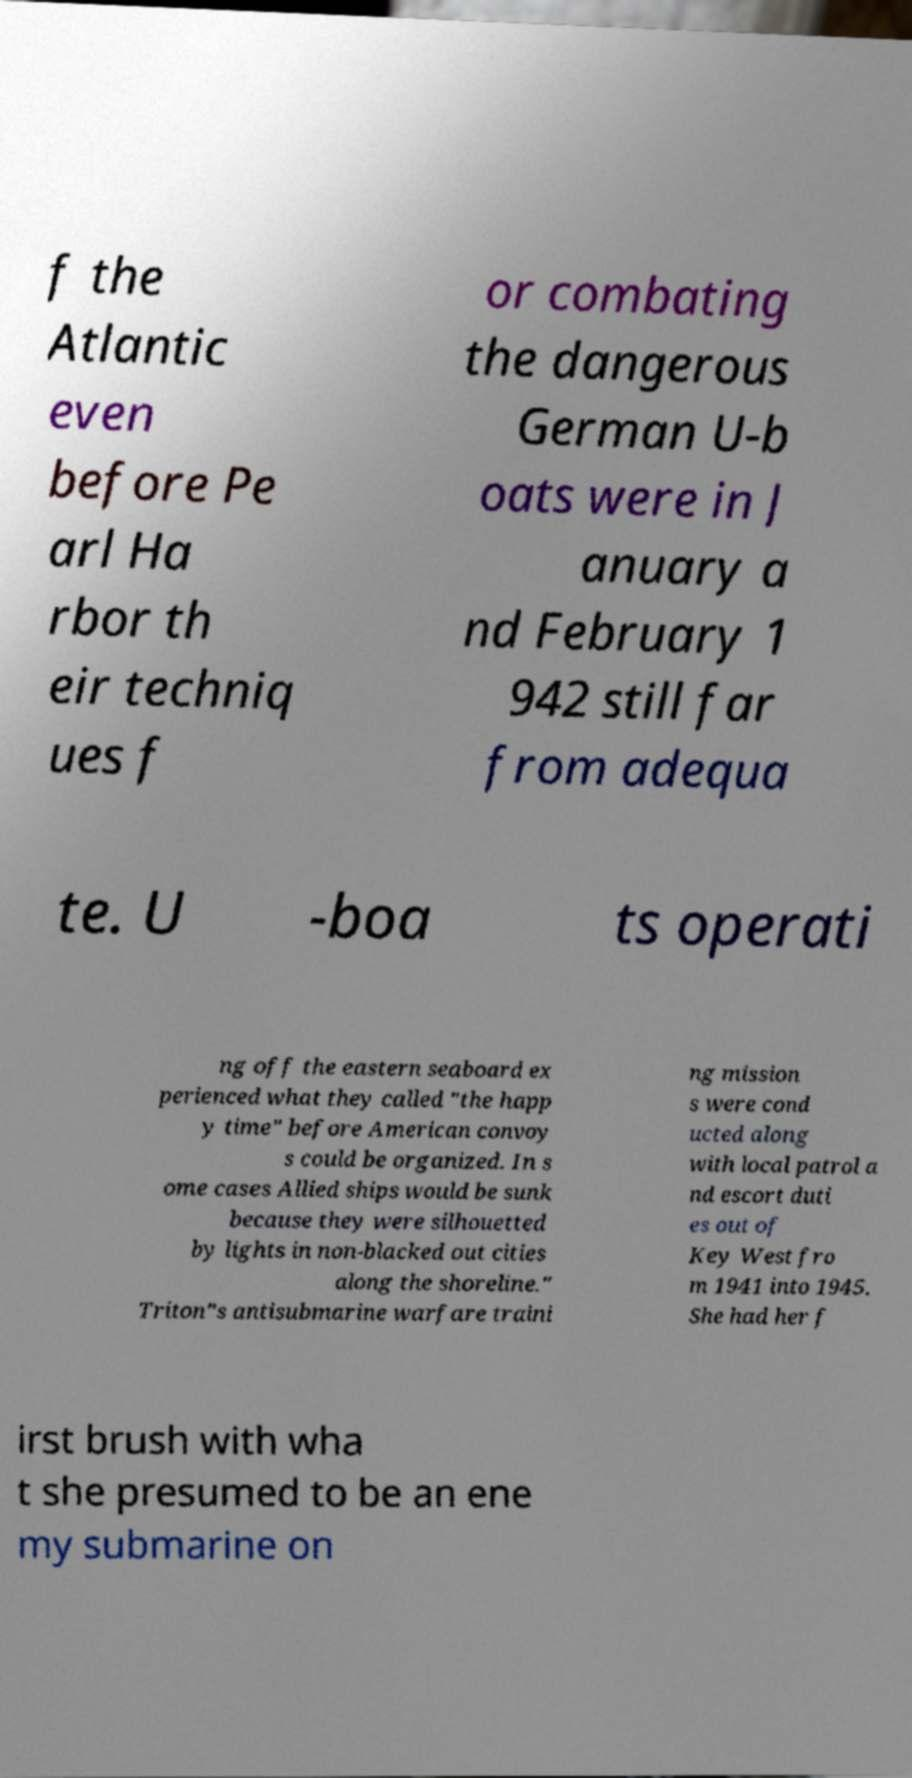What messages or text are displayed in this image? I need them in a readable, typed format. f the Atlantic even before Pe arl Ha rbor th eir techniq ues f or combating the dangerous German U-b oats were in J anuary a nd February 1 942 still far from adequa te. U -boa ts operati ng off the eastern seaboard ex perienced what they called "the happ y time" before American convoy s could be organized. In s ome cases Allied ships would be sunk because they were silhouetted by lights in non-blacked out cities along the shoreline." Triton"s antisubmarine warfare traini ng mission s were cond ucted along with local patrol a nd escort duti es out of Key West fro m 1941 into 1945. She had her f irst brush with wha t she presumed to be an ene my submarine on 